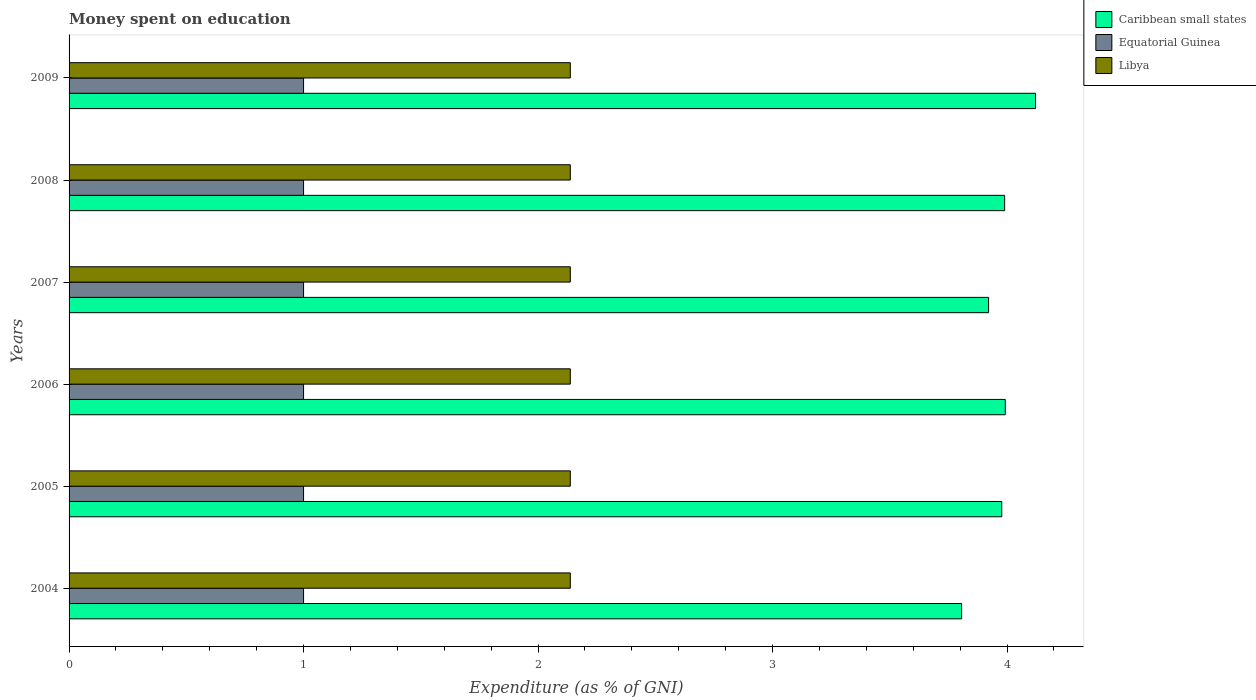How many groups of bars are there?
Your answer should be compact. 6. How many bars are there on the 6th tick from the bottom?
Give a very brief answer. 3. In how many cases, is the number of bars for a given year not equal to the number of legend labels?
Make the answer very short. 0. Across all years, what is the maximum amount of money spent on education in Caribbean small states?
Your answer should be very brief. 4.12. Across all years, what is the minimum amount of money spent on education in Equatorial Guinea?
Keep it short and to the point. 1. In which year was the amount of money spent on education in Caribbean small states maximum?
Offer a terse response. 2009. In which year was the amount of money spent on education in Libya minimum?
Make the answer very short. 2004. What is the total amount of money spent on education in Caribbean small states in the graph?
Ensure brevity in your answer.  23.81. What is the difference between the amount of money spent on education in Caribbean small states in 2006 and that in 2009?
Make the answer very short. -0.13. What is the difference between the amount of money spent on education in Libya in 2004 and the amount of money spent on education in Caribbean small states in 2006?
Offer a terse response. -1.86. What is the average amount of money spent on education in Equatorial Guinea per year?
Make the answer very short. 1. In the year 2004, what is the difference between the amount of money spent on education in Caribbean small states and amount of money spent on education in Equatorial Guinea?
Make the answer very short. 2.81. What is the ratio of the amount of money spent on education in Libya in 2007 to that in 2009?
Your answer should be compact. 1. Is the amount of money spent on education in Libya in 2006 less than that in 2008?
Ensure brevity in your answer.  No. Is the difference between the amount of money spent on education in Caribbean small states in 2008 and 2009 greater than the difference between the amount of money spent on education in Equatorial Guinea in 2008 and 2009?
Offer a terse response. No. What is the difference between the highest and the lowest amount of money spent on education in Equatorial Guinea?
Make the answer very short. 0. Is the sum of the amount of money spent on education in Equatorial Guinea in 2008 and 2009 greater than the maximum amount of money spent on education in Caribbean small states across all years?
Offer a very short reply. No. What does the 2nd bar from the top in 2004 represents?
Your response must be concise. Equatorial Guinea. What does the 1st bar from the bottom in 2007 represents?
Provide a succinct answer. Caribbean small states. How many bars are there?
Provide a succinct answer. 18. What is the difference between two consecutive major ticks on the X-axis?
Your answer should be very brief. 1. Does the graph contain any zero values?
Give a very brief answer. No. Where does the legend appear in the graph?
Ensure brevity in your answer.  Top right. How many legend labels are there?
Ensure brevity in your answer.  3. What is the title of the graph?
Provide a succinct answer. Money spent on education. What is the label or title of the X-axis?
Provide a short and direct response. Expenditure (as % of GNI). What is the Expenditure (as % of GNI) of Caribbean small states in 2004?
Offer a terse response. 3.81. What is the Expenditure (as % of GNI) in Libya in 2004?
Keep it short and to the point. 2.14. What is the Expenditure (as % of GNI) of Caribbean small states in 2005?
Provide a succinct answer. 3.98. What is the Expenditure (as % of GNI) of Equatorial Guinea in 2005?
Provide a succinct answer. 1. What is the Expenditure (as % of GNI) in Libya in 2005?
Make the answer very short. 2.14. What is the Expenditure (as % of GNI) of Caribbean small states in 2006?
Provide a short and direct response. 3.99. What is the Expenditure (as % of GNI) of Libya in 2006?
Your answer should be compact. 2.14. What is the Expenditure (as % of GNI) in Caribbean small states in 2007?
Provide a short and direct response. 3.92. What is the Expenditure (as % of GNI) in Libya in 2007?
Make the answer very short. 2.14. What is the Expenditure (as % of GNI) of Caribbean small states in 2008?
Your answer should be compact. 3.99. What is the Expenditure (as % of GNI) in Libya in 2008?
Provide a succinct answer. 2.14. What is the Expenditure (as % of GNI) in Caribbean small states in 2009?
Offer a terse response. 4.12. What is the Expenditure (as % of GNI) in Libya in 2009?
Your response must be concise. 2.14. Across all years, what is the maximum Expenditure (as % of GNI) in Caribbean small states?
Your response must be concise. 4.12. Across all years, what is the maximum Expenditure (as % of GNI) in Equatorial Guinea?
Your answer should be compact. 1. Across all years, what is the maximum Expenditure (as % of GNI) in Libya?
Provide a succinct answer. 2.14. Across all years, what is the minimum Expenditure (as % of GNI) of Caribbean small states?
Keep it short and to the point. 3.81. Across all years, what is the minimum Expenditure (as % of GNI) of Equatorial Guinea?
Provide a short and direct response. 1. Across all years, what is the minimum Expenditure (as % of GNI) in Libya?
Offer a very short reply. 2.14. What is the total Expenditure (as % of GNI) of Caribbean small states in the graph?
Give a very brief answer. 23.81. What is the total Expenditure (as % of GNI) in Equatorial Guinea in the graph?
Offer a terse response. 6. What is the total Expenditure (as % of GNI) of Libya in the graph?
Provide a short and direct response. 12.82. What is the difference between the Expenditure (as % of GNI) in Caribbean small states in 2004 and that in 2005?
Provide a succinct answer. -0.17. What is the difference between the Expenditure (as % of GNI) in Caribbean small states in 2004 and that in 2006?
Your answer should be compact. -0.19. What is the difference between the Expenditure (as % of GNI) of Equatorial Guinea in 2004 and that in 2006?
Provide a succinct answer. 0. What is the difference between the Expenditure (as % of GNI) in Libya in 2004 and that in 2006?
Make the answer very short. 0. What is the difference between the Expenditure (as % of GNI) of Caribbean small states in 2004 and that in 2007?
Provide a succinct answer. -0.12. What is the difference between the Expenditure (as % of GNI) in Equatorial Guinea in 2004 and that in 2007?
Keep it short and to the point. 0. What is the difference between the Expenditure (as % of GNI) in Caribbean small states in 2004 and that in 2008?
Your answer should be very brief. -0.18. What is the difference between the Expenditure (as % of GNI) in Caribbean small states in 2004 and that in 2009?
Your answer should be compact. -0.32. What is the difference between the Expenditure (as % of GNI) in Equatorial Guinea in 2004 and that in 2009?
Give a very brief answer. 0. What is the difference between the Expenditure (as % of GNI) in Caribbean small states in 2005 and that in 2006?
Keep it short and to the point. -0.02. What is the difference between the Expenditure (as % of GNI) of Equatorial Guinea in 2005 and that in 2006?
Provide a succinct answer. 0. What is the difference between the Expenditure (as % of GNI) of Libya in 2005 and that in 2006?
Your response must be concise. 0. What is the difference between the Expenditure (as % of GNI) of Caribbean small states in 2005 and that in 2007?
Offer a very short reply. 0.06. What is the difference between the Expenditure (as % of GNI) in Equatorial Guinea in 2005 and that in 2007?
Offer a terse response. 0. What is the difference between the Expenditure (as % of GNI) of Libya in 2005 and that in 2007?
Make the answer very short. 0. What is the difference between the Expenditure (as % of GNI) in Caribbean small states in 2005 and that in 2008?
Offer a terse response. -0.01. What is the difference between the Expenditure (as % of GNI) in Caribbean small states in 2005 and that in 2009?
Give a very brief answer. -0.14. What is the difference between the Expenditure (as % of GNI) of Libya in 2005 and that in 2009?
Offer a terse response. 0. What is the difference between the Expenditure (as % of GNI) of Caribbean small states in 2006 and that in 2007?
Provide a succinct answer. 0.07. What is the difference between the Expenditure (as % of GNI) of Equatorial Guinea in 2006 and that in 2007?
Ensure brevity in your answer.  0. What is the difference between the Expenditure (as % of GNI) of Libya in 2006 and that in 2007?
Ensure brevity in your answer.  0. What is the difference between the Expenditure (as % of GNI) in Caribbean small states in 2006 and that in 2008?
Keep it short and to the point. 0. What is the difference between the Expenditure (as % of GNI) in Libya in 2006 and that in 2008?
Offer a very short reply. 0. What is the difference between the Expenditure (as % of GNI) in Caribbean small states in 2006 and that in 2009?
Provide a short and direct response. -0.13. What is the difference between the Expenditure (as % of GNI) of Equatorial Guinea in 2006 and that in 2009?
Keep it short and to the point. 0. What is the difference between the Expenditure (as % of GNI) in Caribbean small states in 2007 and that in 2008?
Keep it short and to the point. -0.07. What is the difference between the Expenditure (as % of GNI) of Caribbean small states in 2007 and that in 2009?
Keep it short and to the point. -0.2. What is the difference between the Expenditure (as % of GNI) in Caribbean small states in 2008 and that in 2009?
Provide a short and direct response. -0.13. What is the difference between the Expenditure (as % of GNI) of Equatorial Guinea in 2008 and that in 2009?
Your answer should be compact. 0. What is the difference between the Expenditure (as % of GNI) of Caribbean small states in 2004 and the Expenditure (as % of GNI) of Equatorial Guinea in 2005?
Your response must be concise. 2.81. What is the difference between the Expenditure (as % of GNI) in Caribbean small states in 2004 and the Expenditure (as % of GNI) in Libya in 2005?
Keep it short and to the point. 1.67. What is the difference between the Expenditure (as % of GNI) of Equatorial Guinea in 2004 and the Expenditure (as % of GNI) of Libya in 2005?
Keep it short and to the point. -1.14. What is the difference between the Expenditure (as % of GNI) in Caribbean small states in 2004 and the Expenditure (as % of GNI) in Equatorial Guinea in 2006?
Your response must be concise. 2.81. What is the difference between the Expenditure (as % of GNI) in Caribbean small states in 2004 and the Expenditure (as % of GNI) in Libya in 2006?
Your answer should be compact. 1.67. What is the difference between the Expenditure (as % of GNI) of Equatorial Guinea in 2004 and the Expenditure (as % of GNI) of Libya in 2006?
Ensure brevity in your answer.  -1.14. What is the difference between the Expenditure (as % of GNI) of Caribbean small states in 2004 and the Expenditure (as % of GNI) of Equatorial Guinea in 2007?
Give a very brief answer. 2.81. What is the difference between the Expenditure (as % of GNI) in Caribbean small states in 2004 and the Expenditure (as % of GNI) in Libya in 2007?
Your answer should be compact. 1.67. What is the difference between the Expenditure (as % of GNI) of Equatorial Guinea in 2004 and the Expenditure (as % of GNI) of Libya in 2007?
Your answer should be compact. -1.14. What is the difference between the Expenditure (as % of GNI) in Caribbean small states in 2004 and the Expenditure (as % of GNI) in Equatorial Guinea in 2008?
Your response must be concise. 2.81. What is the difference between the Expenditure (as % of GNI) in Caribbean small states in 2004 and the Expenditure (as % of GNI) in Libya in 2008?
Keep it short and to the point. 1.67. What is the difference between the Expenditure (as % of GNI) in Equatorial Guinea in 2004 and the Expenditure (as % of GNI) in Libya in 2008?
Keep it short and to the point. -1.14. What is the difference between the Expenditure (as % of GNI) of Caribbean small states in 2004 and the Expenditure (as % of GNI) of Equatorial Guinea in 2009?
Ensure brevity in your answer.  2.81. What is the difference between the Expenditure (as % of GNI) in Caribbean small states in 2004 and the Expenditure (as % of GNI) in Libya in 2009?
Make the answer very short. 1.67. What is the difference between the Expenditure (as % of GNI) in Equatorial Guinea in 2004 and the Expenditure (as % of GNI) in Libya in 2009?
Ensure brevity in your answer.  -1.14. What is the difference between the Expenditure (as % of GNI) of Caribbean small states in 2005 and the Expenditure (as % of GNI) of Equatorial Guinea in 2006?
Offer a very short reply. 2.98. What is the difference between the Expenditure (as % of GNI) in Caribbean small states in 2005 and the Expenditure (as % of GNI) in Libya in 2006?
Offer a terse response. 1.84. What is the difference between the Expenditure (as % of GNI) in Equatorial Guinea in 2005 and the Expenditure (as % of GNI) in Libya in 2006?
Your answer should be very brief. -1.14. What is the difference between the Expenditure (as % of GNI) of Caribbean small states in 2005 and the Expenditure (as % of GNI) of Equatorial Guinea in 2007?
Offer a very short reply. 2.98. What is the difference between the Expenditure (as % of GNI) of Caribbean small states in 2005 and the Expenditure (as % of GNI) of Libya in 2007?
Make the answer very short. 1.84. What is the difference between the Expenditure (as % of GNI) in Equatorial Guinea in 2005 and the Expenditure (as % of GNI) in Libya in 2007?
Your answer should be compact. -1.14. What is the difference between the Expenditure (as % of GNI) in Caribbean small states in 2005 and the Expenditure (as % of GNI) in Equatorial Guinea in 2008?
Provide a short and direct response. 2.98. What is the difference between the Expenditure (as % of GNI) in Caribbean small states in 2005 and the Expenditure (as % of GNI) in Libya in 2008?
Your answer should be very brief. 1.84. What is the difference between the Expenditure (as % of GNI) in Equatorial Guinea in 2005 and the Expenditure (as % of GNI) in Libya in 2008?
Ensure brevity in your answer.  -1.14. What is the difference between the Expenditure (as % of GNI) in Caribbean small states in 2005 and the Expenditure (as % of GNI) in Equatorial Guinea in 2009?
Give a very brief answer. 2.98. What is the difference between the Expenditure (as % of GNI) of Caribbean small states in 2005 and the Expenditure (as % of GNI) of Libya in 2009?
Provide a short and direct response. 1.84. What is the difference between the Expenditure (as % of GNI) in Equatorial Guinea in 2005 and the Expenditure (as % of GNI) in Libya in 2009?
Ensure brevity in your answer.  -1.14. What is the difference between the Expenditure (as % of GNI) in Caribbean small states in 2006 and the Expenditure (as % of GNI) in Equatorial Guinea in 2007?
Keep it short and to the point. 2.99. What is the difference between the Expenditure (as % of GNI) in Caribbean small states in 2006 and the Expenditure (as % of GNI) in Libya in 2007?
Offer a very short reply. 1.86. What is the difference between the Expenditure (as % of GNI) in Equatorial Guinea in 2006 and the Expenditure (as % of GNI) in Libya in 2007?
Make the answer very short. -1.14. What is the difference between the Expenditure (as % of GNI) of Caribbean small states in 2006 and the Expenditure (as % of GNI) of Equatorial Guinea in 2008?
Ensure brevity in your answer.  2.99. What is the difference between the Expenditure (as % of GNI) of Caribbean small states in 2006 and the Expenditure (as % of GNI) of Libya in 2008?
Offer a terse response. 1.86. What is the difference between the Expenditure (as % of GNI) of Equatorial Guinea in 2006 and the Expenditure (as % of GNI) of Libya in 2008?
Offer a terse response. -1.14. What is the difference between the Expenditure (as % of GNI) of Caribbean small states in 2006 and the Expenditure (as % of GNI) of Equatorial Guinea in 2009?
Offer a very short reply. 2.99. What is the difference between the Expenditure (as % of GNI) in Caribbean small states in 2006 and the Expenditure (as % of GNI) in Libya in 2009?
Provide a succinct answer. 1.86. What is the difference between the Expenditure (as % of GNI) of Equatorial Guinea in 2006 and the Expenditure (as % of GNI) of Libya in 2009?
Offer a terse response. -1.14. What is the difference between the Expenditure (as % of GNI) of Caribbean small states in 2007 and the Expenditure (as % of GNI) of Equatorial Guinea in 2008?
Give a very brief answer. 2.92. What is the difference between the Expenditure (as % of GNI) in Caribbean small states in 2007 and the Expenditure (as % of GNI) in Libya in 2008?
Make the answer very short. 1.78. What is the difference between the Expenditure (as % of GNI) of Equatorial Guinea in 2007 and the Expenditure (as % of GNI) of Libya in 2008?
Offer a very short reply. -1.14. What is the difference between the Expenditure (as % of GNI) of Caribbean small states in 2007 and the Expenditure (as % of GNI) of Equatorial Guinea in 2009?
Offer a very short reply. 2.92. What is the difference between the Expenditure (as % of GNI) in Caribbean small states in 2007 and the Expenditure (as % of GNI) in Libya in 2009?
Ensure brevity in your answer.  1.78. What is the difference between the Expenditure (as % of GNI) in Equatorial Guinea in 2007 and the Expenditure (as % of GNI) in Libya in 2009?
Ensure brevity in your answer.  -1.14. What is the difference between the Expenditure (as % of GNI) of Caribbean small states in 2008 and the Expenditure (as % of GNI) of Equatorial Guinea in 2009?
Your answer should be very brief. 2.99. What is the difference between the Expenditure (as % of GNI) of Caribbean small states in 2008 and the Expenditure (as % of GNI) of Libya in 2009?
Your answer should be compact. 1.85. What is the difference between the Expenditure (as % of GNI) of Equatorial Guinea in 2008 and the Expenditure (as % of GNI) of Libya in 2009?
Ensure brevity in your answer.  -1.14. What is the average Expenditure (as % of GNI) in Caribbean small states per year?
Provide a succinct answer. 3.97. What is the average Expenditure (as % of GNI) of Equatorial Guinea per year?
Your answer should be compact. 1. What is the average Expenditure (as % of GNI) in Libya per year?
Provide a succinct answer. 2.14. In the year 2004, what is the difference between the Expenditure (as % of GNI) in Caribbean small states and Expenditure (as % of GNI) in Equatorial Guinea?
Your answer should be very brief. 2.81. In the year 2004, what is the difference between the Expenditure (as % of GNI) of Caribbean small states and Expenditure (as % of GNI) of Libya?
Offer a terse response. 1.67. In the year 2004, what is the difference between the Expenditure (as % of GNI) in Equatorial Guinea and Expenditure (as % of GNI) in Libya?
Ensure brevity in your answer.  -1.14. In the year 2005, what is the difference between the Expenditure (as % of GNI) in Caribbean small states and Expenditure (as % of GNI) in Equatorial Guinea?
Provide a short and direct response. 2.98. In the year 2005, what is the difference between the Expenditure (as % of GNI) of Caribbean small states and Expenditure (as % of GNI) of Libya?
Your answer should be compact. 1.84. In the year 2005, what is the difference between the Expenditure (as % of GNI) of Equatorial Guinea and Expenditure (as % of GNI) of Libya?
Offer a terse response. -1.14. In the year 2006, what is the difference between the Expenditure (as % of GNI) in Caribbean small states and Expenditure (as % of GNI) in Equatorial Guinea?
Ensure brevity in your answer.  2.99. In the year 2006, what is the difference between the Expenditure (as % of GNI) of Caribbean small states and Expenditure (as % of GNI) of Libya?
Give a very brief answer. 1.86. In the year 2006, what is the difference between the Expenditure (as % of GNI) of Equatorial Guinea and Expenditure (as % of GNI) of Libya?
Your response must be concise. -1.14. In the year 2007, what is the difference between the Expenditure (as % of GNI) in Caribbean small states and Expenditure (as % of GNI) in Equatorial Guinea?
Provide a succinct answer. 2.92. In the year 2007, what is the difference between the Expenditure (as % of GNI) in Caribbean small states and Expenditure (as % of GNI) in Libya?
Give a very brief answer. 1.78. In the year 2007, what is the difference between the Expenditure (as % of GNI) in Equatorial Guinea and Expenditure (as % of GNI) in Libya?
Provide a short and direct response. -1.14. In the year 2008, what is the difference between the Expenditure (as % of GNI) of Caribbean small states and Expenditure (as % of GNI) of Equatorial Guinea?
Your response must be concise. 2.99. In the year 2008, what is the difference between the Expenditure (as % of GNI) in Caribbean small states and Expenditure (as % of GNI) in Libya?
Your answer should be very brief. 1.85. In the year 2008, what is the difference between the Expenditure (as % of GNI) in Equatorial Guinea and Expenditure (as % of GNI) in Libya?
Your answer should be very brief. -1.14. In the year 2009, what is the difference between the Expenditure (as % of GNI) in Caribbean small states and Expenditure (as % of GNI) in Equatorial Guinea?
Your answer should be compact. 3.12. In the year 2009, what is the difference between the Expenditure (as % of GNI) of Caribbean small states and Expenditure (as % of GNI) of Libya?
Make the answer very short. 1.98. In the year 2009, what is the difference between the Expenditure (as % of GNI) of Equatorial Guinea and Expenditure (as % of GNI) of Libya?
Provide a succinct answer. -1.14. What is the ratio of the Expenditure (as % of GNI) of Caribbean small states in 2004 to that in 2005?
Make the answer very short. 0.96. What is the ratio of the Expenditure (as % of GNI) of Caribbean small states in 2004 to that in 2006?
Ensure brevity in your answer.  0.95. What is the ratio of the Expenditure (as % of GNI) in Libya in 2004 to that in 2006?
Your answer should be very brief. 1. What is the ratio of the Expenditure (as % of GNI) in Caribbean small states in 2004 to that in 2007?
Offer a terse response. 0.97. What is the ratio of the Expenditure (as % of GNI) in Equatorial Guinea in 2004 to that in 2007?
Offer a very short reply. 1. What is the ratio of the Expenditure (as % of GNI) of Caribbean small states in 2004 to that in 2008?
Provide a succinct answer. 0.95. What is the ratio of the Expenditure (as % of GNI) in Libya in 2004 to that in 2008?
Provide a short and direct response. 1. What is the ratio of the Expenditure (as % of GNI) of Caribbean small states in 2004 to that in 2009?
Your answer should be compact. 0.92. What is the ratio of the Expenditure (as % of GNI) in Equatorial Guinea in 2004 to that in 2009?
Ensure brevity in your answer.  1. What is the ratio of the Expenditure (as % of GNI) in Caribbean small states in 2005 to that in 2006?
Your response must be concise. 1. What is the ratio of the Expenditure (as % of GNI) in Equatorial Guinea in 2005 to that in 2006?
Your answer should be compact. 1. What is the ratio of the Expenditure (as % of GNI) in Libya in 2005 to that in 2006?
Ensure brevity in your answer.  1. What is the ratio of the Expenditure (as % of GNI) of Caribbean small states in 2005 to that in 2007?
Ensure brevity in your answer.  1.01. What is the ratio of the Expenditure (as % of GNI) of Caribbean small states in 2005 to that in 2008?
Your answer should be compact. 1. What is the ratio of the Expenditure (as % of GNI) of Equatorial Guinea in 2005 to that in 2008?
Your answer should be very brief. 1. What is the ratio of the Expenditure (as % of GNI) in Caribbean small states in 2005 to that in 2009?
Your answer should be very brief. 0.97. What is the ratio of the Expenditure (as % of GNI) in Equatorial Guinea in 2005 to that in 2009?
Your answer should be very brief. 1. What is the ratio of the Expenditure (as % of GNI) of Caribbean small states in 2006 to that in 2007?
Provide a succinct answer. 1.02. What is the ratio of the Expenditure (as % of GNI) in Caribbean small states in 2006 to that in 2009?
Ensure brevity in your answer.  0.97. What is the ratio of the Expenditure (as % of GNI) of Equatorial Guinea in 2006 to that in 2009?
Your response must be concise. 1. What is the ratio of the Expenditure (as % of GNI) of Caribbean small states in 2007 to that in 2008?
Keep it short and to the point. 0.98. What is the ratio of the Expenditure (as % of GNI) in Caribbean small states in 2007 to that in 2009?
Your answer should be very brief. 0.95. What is the ratio of the Expenditure (as % of GNI) in Equatorial Guinea in 2007 to that in 2009?
Your response must be concise. 1. What is the ratio of the Expenditure (as % of GNI) in Libya in 2007 to that in 2009?
Provide a succinct answer. 1. What is the ratio of the Expenditure (as % of GNI) in Caribbean small states in 2008 to that in 2009?
Give a very brief answer. 0.97. What is the ratio of the Expenditure (as % of GNI) of Equatorial Guinea in 2008 to that in 2009?
Give a very brief answer. 1. What is the difference between the highest and the second highest Expenditure (as % of GNI) of Caribbean small states?
Ensure brevity in your answer.  0.13. What is the difference between the highest and the second highest Expenditure (as % of GNI) of Equatorial Guinea?
Offer a very short reply. 0. What is the difference between the highest and the second highest Expenditure (as % of GNI) of Libya?
Offer a terse response. 0. What is the difference between the highest and the lowest Expenditure (as % of GNI) of Caribbean small states?
Provide a succinct answer. 0.32. What is the difference between the highest and the lowest Expenditure (as % of GNI) in Equatorial Guinea?
Your answer should be very brief. 0. 